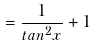<formula> <loc_0><loc_0><loc_500><loc_500>= \frac { 1 } { t a n ^ { 2 } x } + 1</formula> 